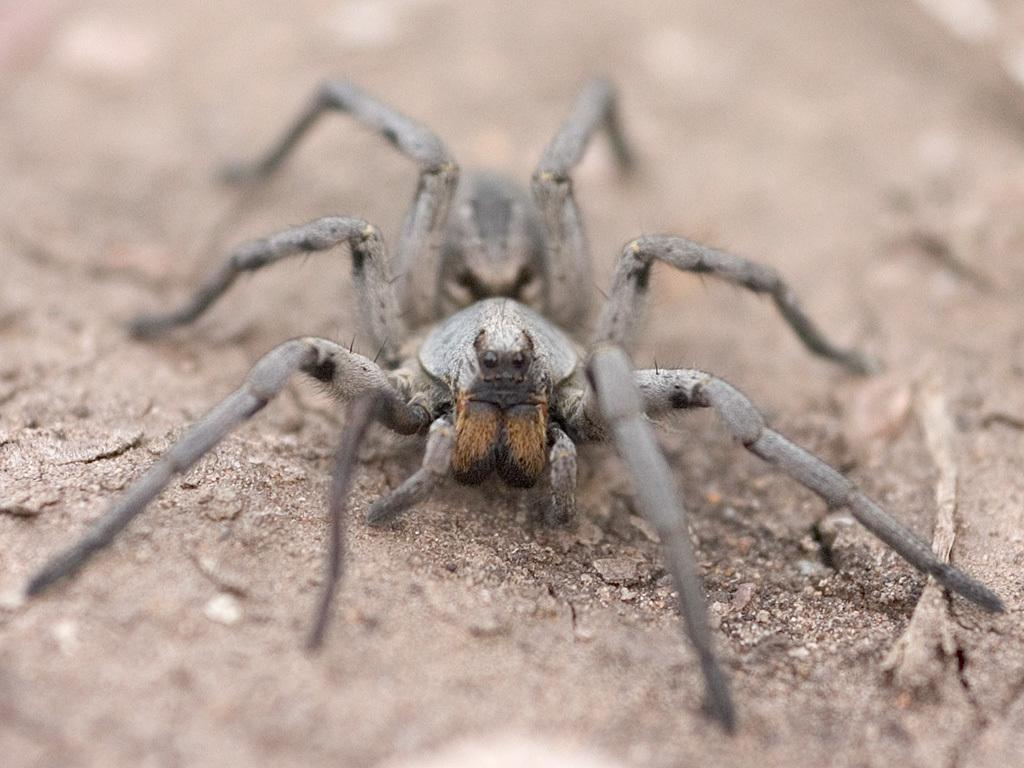What is the main subject of the image? There is a spider in the image. Where is the spider located? The spider is on the sand. Can you describe the background of the image? The background of the image is blurry. What verse is the spider reciting in the image? There is no indication in the image that the spider is reciting a verse, as spiders do not have the ability to speak or recite poetry. 